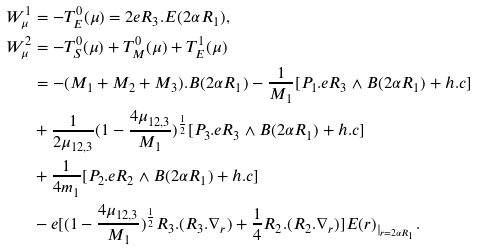<formula> <loc_0><loc_0><loc_500><loc_500>W ^ { 1 } _ { \mu } & = - T _ { E } ^ { 0 } ( \mu ) = 2 e R _ { 3 } . E ( 2 \alpha R _ { 1 } ) , \\ W ^ { 2 } _ { \mu } & = - T _ { S } ^ { 0 } ( \mu ) + T _ { M } ^ { 0 } ( \mu ) + T _ { E } ^ { 1 } ( \mu ) \\ & = - ( M _ { 1 } + M _ { 2 } + M _ { 3 } ) . B ( 2 \alpha R _ { 1 } ) - \frac { 1 } { M _ { 1 } } [ P _ { 1 } . e R _ { 3 } \wedge B ( 2 \alpha R _ { 1 } ) + h . c ] \\ & + \frac { 1 } { 2 \mu _ { 1 2 , 3 } } ( 1 - \frac { 4 \mu _ { 1 2 , 3 } } { M _ { 1 } } ) ^ { \frac { 1 } { 2 } } [ P _ { 3 } . e R _ { 3 } \wedge B ( 2 \alpha R _ { 1 } ) + h . c ] \\ & + \frac { 1 } { 4 m _ { 1 } } [ P _ { 2 } . e R _ { 2 } \wedge B ( 2 \alpha R _ { 1 } ) + h . c ] \\ & - e [ ( 1 - \frac { 4 \mu _ { 1 2 , 3 } } { M _ { 1 } } ) ^ { \frac { 1 } { 2 } } R _ { 3 } . ( R _ { 3 } . \nabla _ { r } ) + \frac { 1 } { 4 } R _ { 2 } . ( R _ { 2 } . \nabla _ { r } ) ] E ( r ) _ { | _ { r = 2 \alpha R _ { 1 } } } .</formula> 